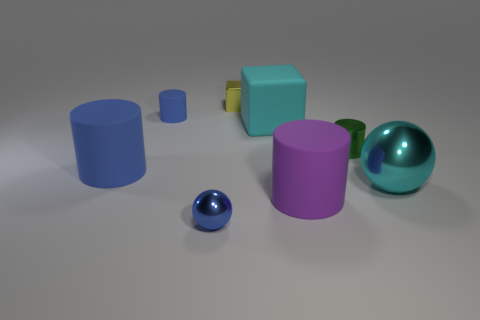How many things are both behind the big blue rubber cylinder and left of the purple rubber cylinder?
Give a very brief answer. 3. Is there any other thing that is the same color as the metallic cylinder?
Your answer should be compact. No. There is a big blue object that is the same material as the purple cylinder; what is its shape?
Provide a short and direct response. Cylinder. Do the yellow object and the cyan block have the same size?
Your answer should be very brief. No. Are the big cyan thing on the left side of the purple object and the blue ball made of the same material?
Give a very brief answer. No. Is there anything else that has the same material as the small green object?
Your answer should be compact. Yes. How many tiny spheres are in front of the tiny blue object in front of the large matte cylinder that is to the right of the tiny blue matte thing?
Your response must be concise. 0. Do the tiny metallic object that is on the left side of the yellow shiny object and the big purple object have the same shape?
Provide a short and direct response. No. What number of objects are matte cubes or big purple rubber objects that are in front of the big cyan ball?
Give a very brief answer. 2. Are there more small yellow things behind the yellow shiny cube than large cyan things?
Give a very brief answer. No. 